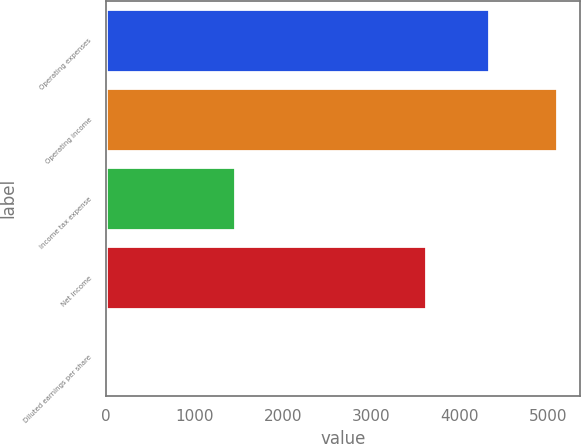Convert chart to OTSL. <chart><loc_0><loc_0><loc_500><loc_500><bar_chart><fcel>Operating expenses<fcel>Operating income<fcel>Income tax expense<fcel>Net income<fcel>Diluted earnings per share<nl><fcel>4335<fcel>5106<fcel>1462<fcel>3617<fcel>3.1<nl></chart> 